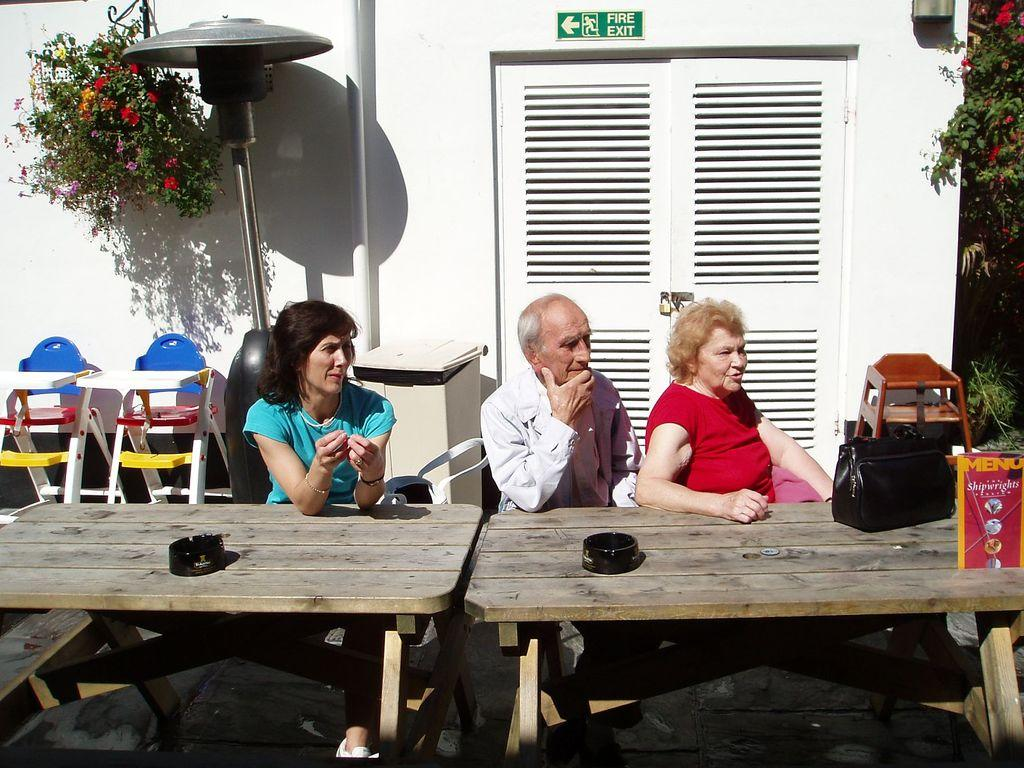What type of living organism can be seen in the image? There is a plant in the image. What is the color of the wall in the image? There is a white color wall in the image. What architectural feature is present in the image? There is a door in the image. How many people are sitting in the image? There are three people sitting on chairs in the image. What piece of furniture is present in the image? There is a table in the image. What type of plate is being used by the donkey in the image? There is no donkey present in the image, and therefore no plate can be associated with it. 